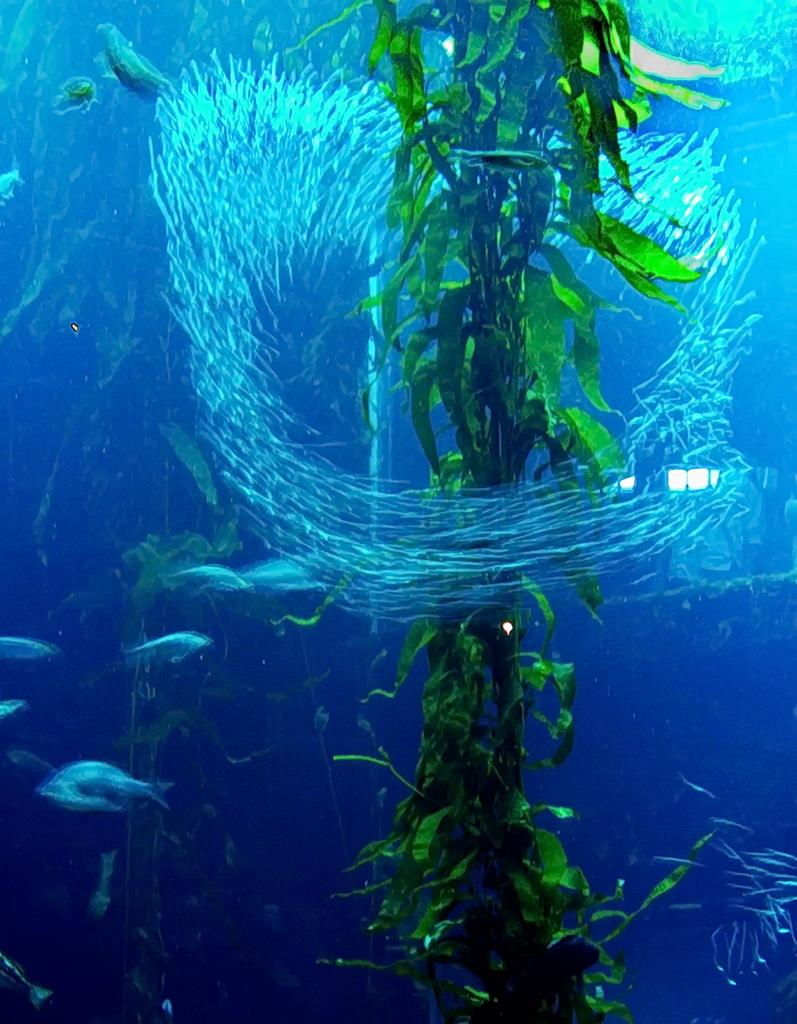What type of environment is shown in the image? The image depicts an underwater environment. What type of marine life can be seen in the image? There are fishes in the image. What else can be seen in the underwater environment? There are plants in the image. Can you see any agreements being signed by the fishes in the image? There are no agreements or any indication of signing in the image; it depicts an underwater environment with fishes and plants. Where is the bee in the image? There is no bee present in the image; it depicts an underwater environment with fishes and plants. 